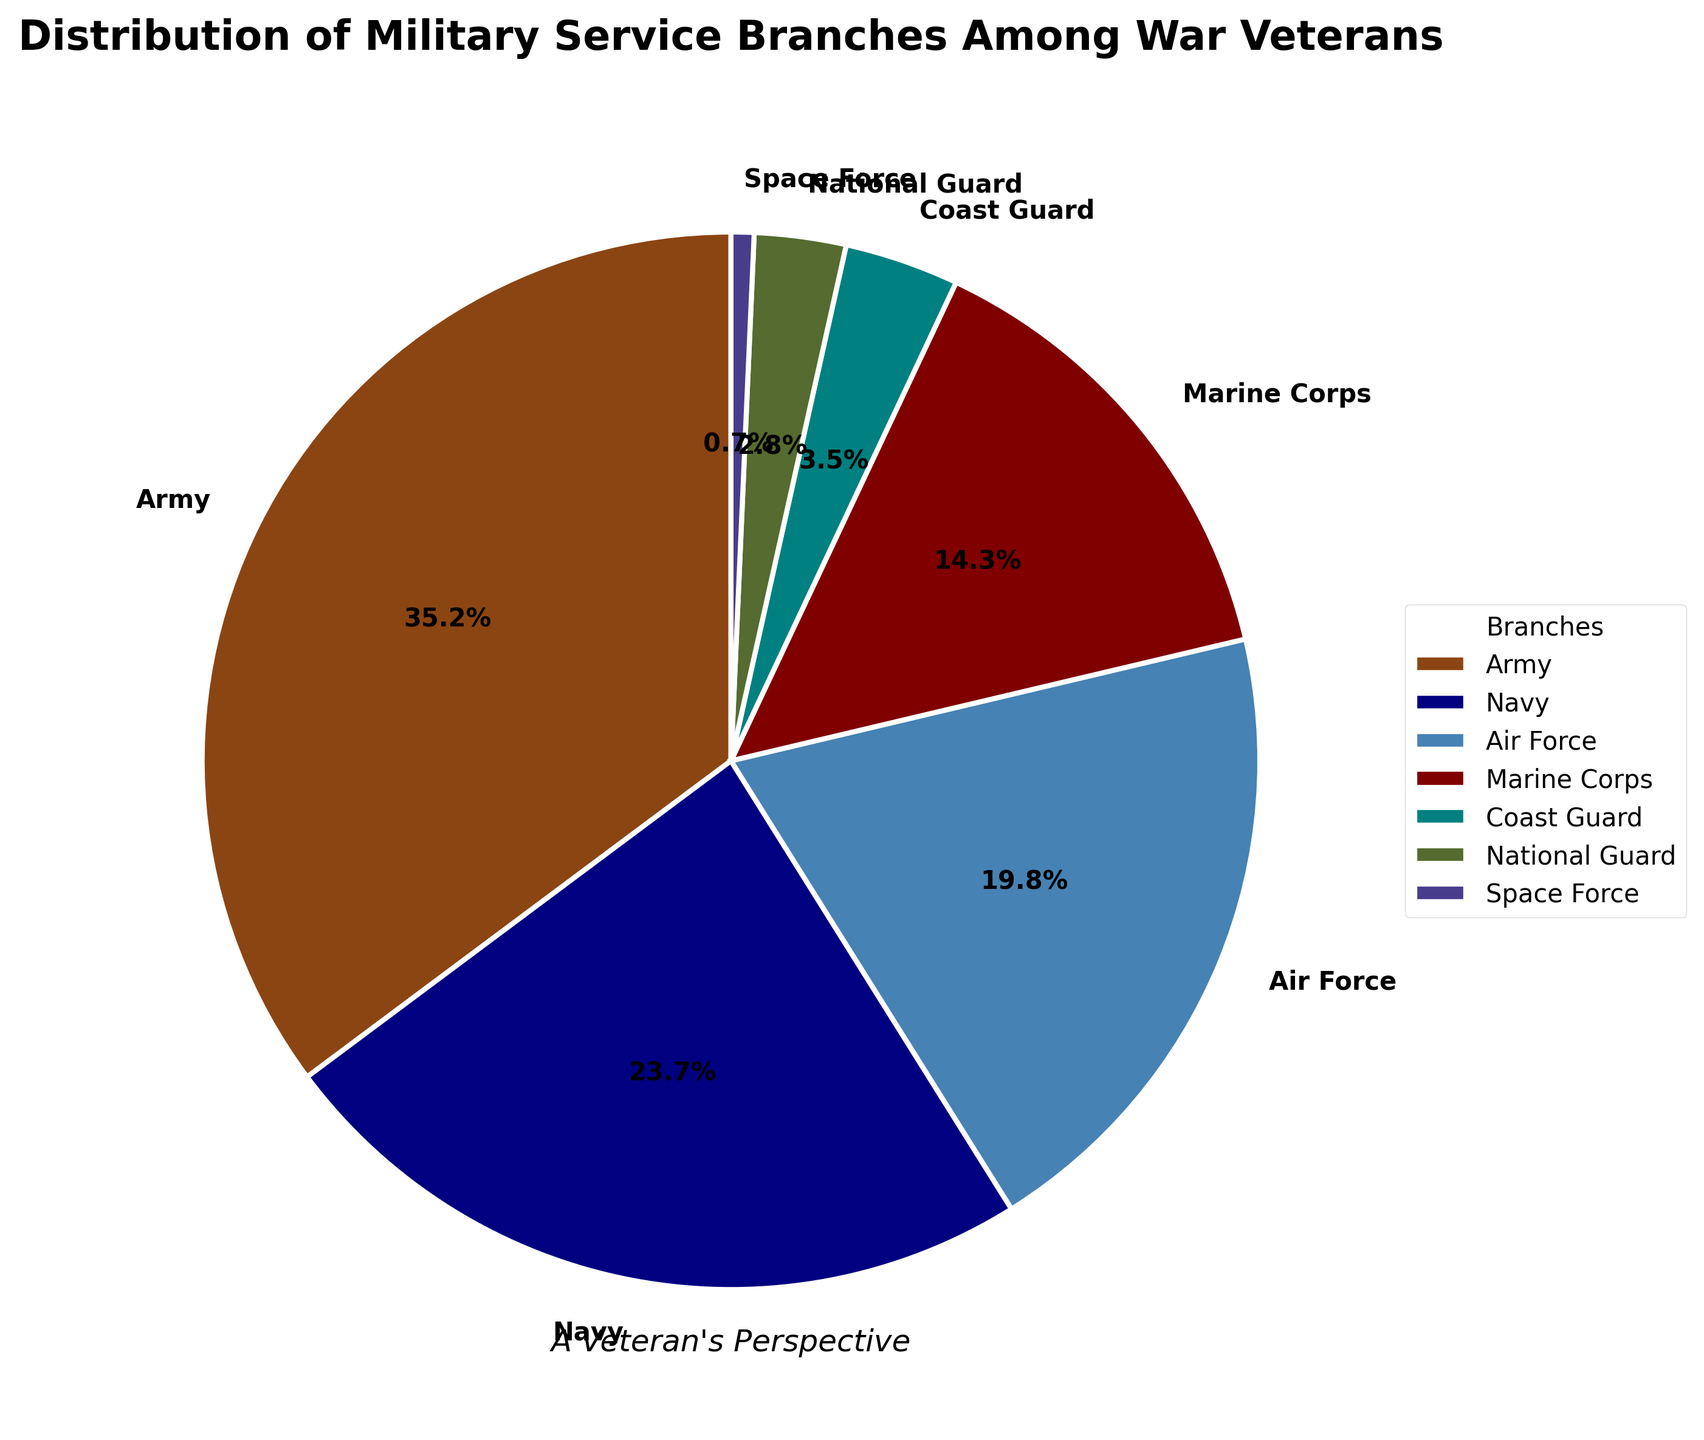How many war veterans served in the Army and Navy combined? According to the pie chart, the Army accounts for 35.2% and the Navy accounts for 23.7%. Adding these percentages together, 35.2 + 23.7 = 58.9%.
Answer: 58.9% What percentage of war veterans served in branches other than the Army? The Army's share is 35.2%. By subtracting this from 100%, we get 100% - 35.2% = 64.8%.
Answer: 64.8% Which branch has the largest representation among war veterans? The pie chart shows that the Army has the largest slice, representing 35.2%.
Answer: Army Which two branches have the smallest representation among war veterans? From the chart, the Space Force (0.7%) and the National Guard (2.8%) have the smallest portions.
Answer: Space Force and National Guard Is the percentage of war veterans in the Air Force greater than those in the Marine Corps? The chart indicates that the Air Force has 19.8%, whereas the Marine Corps has 14.3%. Since 19.8% > 14.3%, the Air Force has more representation.
Answer: Yes What's the total percentage of war veterans who served in the Coast Guard or the National Guard? According to the pie chart, 3.5% served in the Coast Guard, and 2.8% served in the National Guard. Adding these together, 3.5% + 2.8% = 6.3%.
Answer: 6.3% Are there any branches with a representation of less than 5%? If so, which ones? The pie chart shows that the Coast Guard (3.5%), National Guard (2.8%), and Space Force (0.7%) each have less than 5%.
Answer: Coast Guard, National Guard, and Space Force How many branches have more than 20% representation among war veterans? The chart shows the Army (35.2%) and the Navy (23.7%) both exceed 20%.
Answer: Two Compare the combined representation of the Marine Corps and Coast Guard to the percentage of Army veterans. Which is greater? The Marine Corps represents 14.3% and the Coast Guard 3.5%, making their combined total 14.3% + 3.5% = 17.8%. The Army represents 35.2%. Since 17.8% is less than 35.2%, the Army has a greater representation.
Answer: Army Which branch has a deeper shade of blue in the pie chart? The Navy slice in the pie chart is a darker shade of blue compared to other sections.
Answer: Navy 